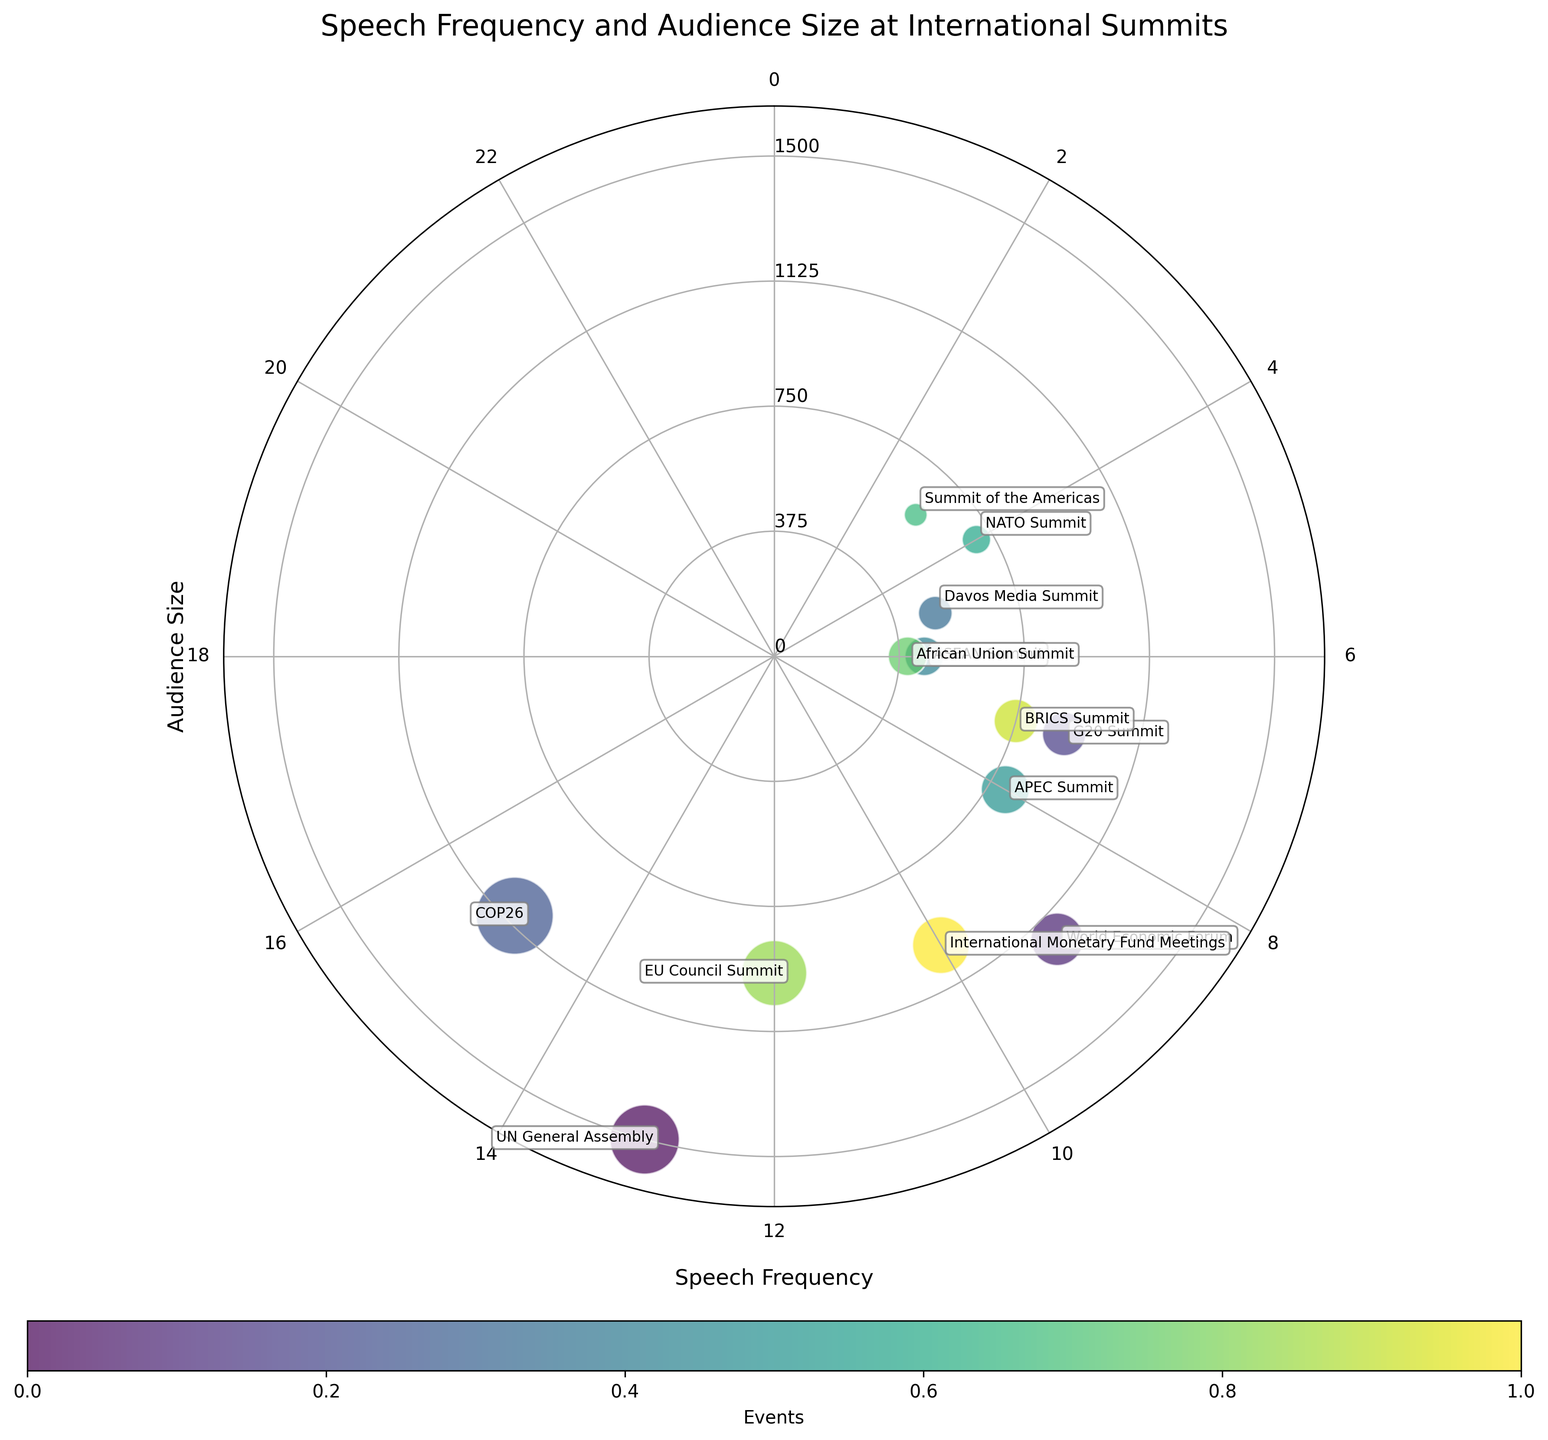What is the title of the figure? The title of the figure is usually displayed at the top of the chart. In this case, it reads "Speech Frequency and Audience Size at International Summits".
Answer: Speech Frequency and Audience Size at International Summits How many data points are represented in the chart? Count each individual scatter point on the chart. Each point corresponds to one data event listed in the dataset.
Answer: 13 Which event has the smallest audience size? Look at the radius (distance from the center) of each point to identify the smallest one. The event Davos Media Summit is closest to the center, meaning it has the smallest audience size.
Answer: Davos Media Summit Which event is the most frequent in speech frequency? The position along the angular axis indicates speech frequency. Find the point at the highest angle (15 in radians) which will be around the outermost circle. This corresponds to COP26.
Answer: COP26 Which two events have an equal speech frequency but different audience sizes? Compare the angles of the points to identify ones with the same angular position but different radii. The events African Union Summit and ASEAN Summit both have the same speech frequency but different audience sizes.
Answer: African Union Summit and ASEAN Summit What is the average audience size of the events plotted? Sum the audience sizes for all events (1500 + 1200 + 900 + 1100 + 500 + 450 + 800 + 700 + 600 + 400 + 950 + 750 + 1000 = 11850) and divide by the number of events (13).
Answer: 911.54 How many events have a speech frequency greater than 10? Find the points whose angular position is above the 10 mark. This corresponds to the events with speech frequency greater than 10. The events are UN General Assembly, COP26, and EU Council Summit.
Answer: 3 Compare the audience size of the G20 Summit and the International Monetary Fund Meetings. Which event has the larger audience? Look at the radial positions of the points for both events. The International Monetary Fund Meetings has a larger radial distance (indicating larger audience size) compared to the G20 Summit.
Answer: International Monetary Fund Meetings What is the median audience size for the events listed? To find the median, list the audience sizes in ascending order and select the middle value: (400, 450, 500, 600, 700, 750, 800, 900, 950, 1000, 1100, 1200, 1500). The median value is the 7th element in this ordered list, which is 800.
Answer: 800 What is the relationship between speech frequency and audience size in the figure? Observing the scatter points, it can be noticed that there isn't a direct linear relationship since high speech frequencies don't necessarily correlate with higher audience sizes and vice versa.
Answer: No direct linear relationship 